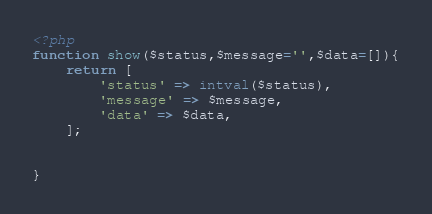<code> <loc_0><loc_0><loc_500><loc_500><_PHP_><?php
function show($status,$message='',$data=[]){
    return [
        'status' => intval($status),
        'message' => $message,
        'data' => $data,
    ];


}</code> 